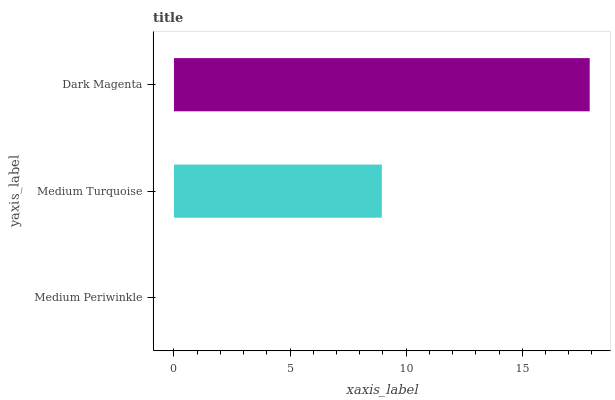Is Medium Periwinkle the minimum?
Answer yes or no. Yes. Is Dark Magenta the maximum?
Answer yes or no. Yes. Is Medium Turquoise the minimum?
Answer yes or no. No. Is Medium Turquoise the maximum?
Answer yes or no. No. Is Medium Turquoise greater than Medium Periwinkle?
Answer yes or no. Yes. Is Medium Periwinkle less than Medium Turquoise?
Answer yes or no. Yes. Is Medium Periwinkle greater than Medium Turquoise?
Answer yes or no. No. Is Medium Turquoise less than Medium Periwinkle?
Answer yes or no. No. Is Medium Turquoise the high median?
Answer yes or no. Yes. Is Medium Turquoise the low median?
Answer yes or no. Yes. Is Medium Periwinkle the high median?
Answer yes or no. No. Is Dark Magenta the low median?
Answer yes or no. No. 